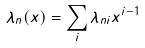<formula> <loc_0><loc_0><loc_500><loc_500>\lambda _ { n } ( x ) = \sum _ { i } \lambda _ { n i } x ^ { i - 1 }</formula> 